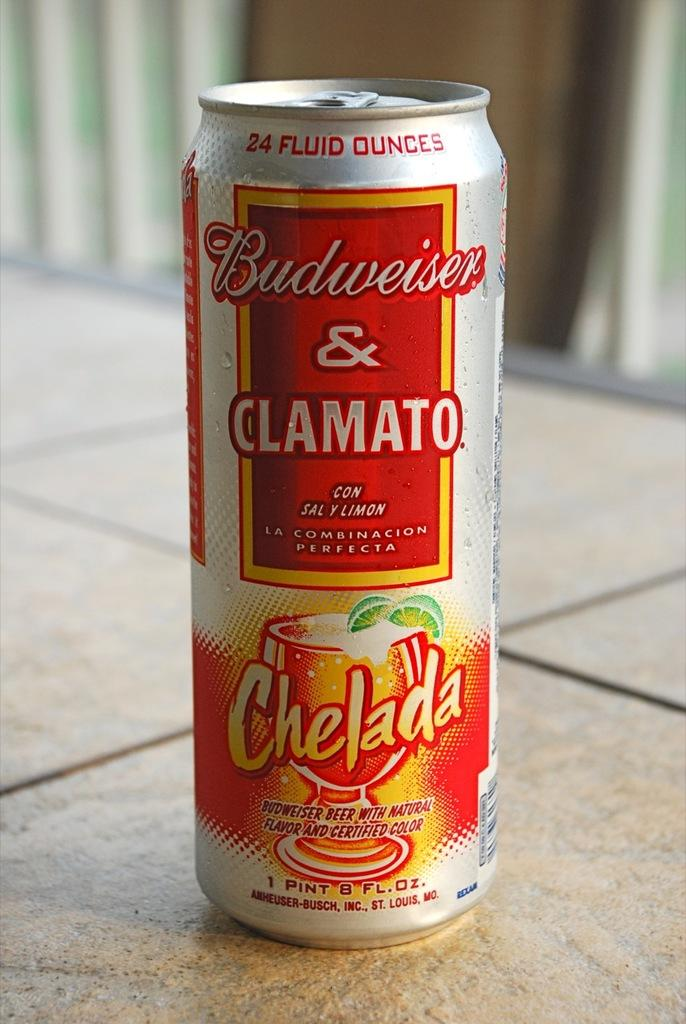<image>
Present a compact description of the photo's key features. A can of drink which has the words Budweiser & Clamato on it. 